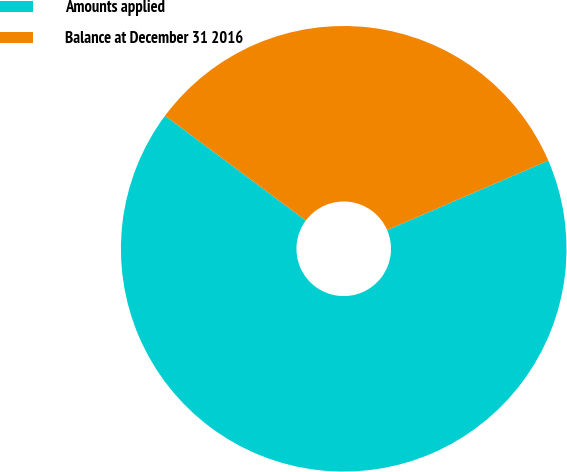Convert chart. <chart><loc_0><loc_0><loc_500><loc_500><pie_chart><fcel>Amounts applied<fcel>Balance at December 31 2016<nl><fcel>66.67%<fcel>33.33%<nl></chart> 